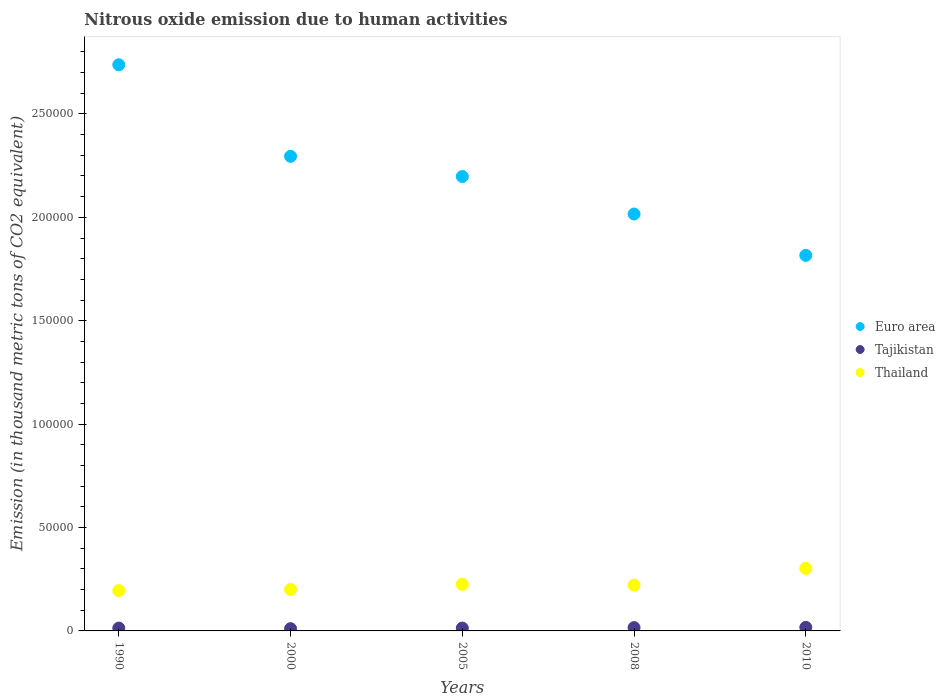How many different coloured dotlines are there?
Keep it short and to the point. 3. What is the amount of nitrous oxide emitted in Tajikistan in 2010?
Offer a very short reply. 1717.6. Across all years, what is the maximum amount of nitrous oxide emitted in Thailand?
Give a very brief answer. 3.02e+04. Across all years, what is the minimum amount of nitrous oxide emitted in Tajikistan?
Keep it short and to the point. 1092.8. In which year was the amount of nitrous oxide emitted in Euro area maximum?
Your answer should be very brief. 1990. In which year was the amount of nitrous oxide emitted in Tajikistan minimum?
Offer a very short reply. 2000. What is the total amount of nitrous oxide emitted in Euro area in the graph?
Offer a terse response. 1.11e+06. What is the difference between the amount of nitrous oxide emitted in Tajikistan in 1990 and that in 2008?
Your answer should be compact. -216.4. What is the difference between the amount of nitrous oxide emitted in Thailand in 2010 and the amount of nitrous oxide emitted in Tajikistan in 2008?
Keep it short and to the point. 2.87e+04. What is the average amount of nitrous oxide emitted in Tajikistan per year?
Keep it short and to the point. 1432.56. In the year 2005, what is the difference between the amount of nitrous oxide emitted in Tajikistan and amount of nitrous oxide emitted in Thailand?
Keep it short and to the point. -2.12e+04. In how many years, is the amount of nitrous oxide emitted in Euro area greater than 110000 thousand metric tons?
Offer a terse response. 5. What is the ratio of the amount of nitrous oxide emitted in Euro area in 1990 to that in 2005?
Provide a succinct answer. 1.25. Is the amount of nitrous oxide emitted in Thailand in 1990 less than that in 2000?
Ensure brevity in your answer.  Yes. What is the difference between the highest and the second highest amount of nitrous oxide emitted in Euro area?
Provide a short and direct response. 4.43e+04. What is the difference between the highest and the lowest amount of nitrous oxide emitted in Euro area?
Ensure brevity in your answer.  9.22e+04. Is the sum of the amount of nitrous oxide emitted in Tajikistan in 1990 and 2005 greater than the maximum amount of nitrous oxide emitted in Euro area across all years?
Provide a succinct answer. No. Is it the case that in every year, the sum of the amount of nitrous oxide emitted in Tajikistan and amount of nitrous oxide emitted in Euro area  is greater than the amount of nitrous oxide emitted in Thailand?
Offer a terse response. Yes. How many dotlines are there?
Give a very brief answer. 3. How many years are there in the graph?
Offer a terse response. 5. What is the difference between two consecutive major ticks on the Y-axis?
Provide a short and direct response. 5.00e+04. Are the values on the major ticks of Y-axis written in scientific E-notation?
Your answer should be very brief. No. Does the graph contain any zero values?
Your response must be concise. No. Does the graph contain grids?
Ensure brevity in your answer.  No. Where does the legend appear in the graph?
Your answer should be compact. Center right. How are the legend labels stacked?
Keep it short and to the point. Vertical. What is the title of the graph?
Provide a short and direct response. Nitrous oxide emission due to human activities. What is the label or title of the Y-axis?
Your answer should be very brief. Emission (in thousand metric tons of CO2 equivalent). What is the Emission (in thousand metric tons of CO2 equivalent) of Euro area in 1990?
Make the answer very short. 2.74e+05. What is the Emission (in thousand metric tons of CO2 equivalent) of Tajikistan in 1990?
Offer a terse response. 1377.2. What is the Emission (in thousand metric tons of CO2 equivalent) in Thailand in 1990?
Your answer should be compact. 1.95e+04. What is the Emission (in thousand metric tons of CO2 equivalent) of Euro area in 2000?
Provide a short and direct response. 2.30e+05. What is the Emission (in thousand metric tons of CO2 equivalent) of Tajikistan in 2000?
Provide a succinct answer. 1092.8. What is the Emission (in thousand metric tons of CO2 equivalent) of Thailand in 2000?
Provide a short and direct response. 2.01e+04. What is the Emission (in thousand metric tons of CO2 equivalent) in Euro area in 2005?
Offer a very short reply. 2.20e+05. What is the Emission (in thousand metric tons of CO2 equivalent) of Tajikistan in 2005?
Your answer should be compact. 1381.6. What is the Emission (in thousand metric tons of CO2 equivalent) of Thailand in 2005?
Ensure brevity in your answer.  2.26e+04. What is the Emission (in thousand metric tons of CO2 equivalent) in Euro area in 2008?
Provide a short and direct response. 2.02e+05. What is the Emission (in thousand metric tons of CO2 equivalent) of Tajikistan in 2008?
Provide a short and direct response. 1593.6. What is the Emission (in thousand metric tons of CO2 equivalent) of Thailand in 2008?
Offer a very short reply. 2.22e+04. What is the Emission (in thousand metric tons of CO2 equivalent) in Euro area in 2010?
Your answer should be very brief. 1.82e+05. What is the Emission (in thousand metric tons of CO2 equivalent) of Tajikistan in 2010?
Make the answer very short. 1717.6. What is the Emission (in thousand metric tons of CO2 equivalent) of Thailand in 2010?
Your answer should be compact. 3.02e+04. Across all years, what is the maximum Emission (in thousand metric tons of CO2 equivalent) of Euro area?
Offer a terse response. 2.74e+05. Across all years, what is the maximum Emission (in thousand metric tons of CO2 equivalent) of Tajikistan?
Make the answer very short. 1717.6. Across all years, what is the maximum Emission (in thousand metric tons of CO2 equivalent) in Thailand?
Keep it short and to the point. 3.02e+04. Across all years, what is the minimum Emission (in thousand metric tons of CO2 equivalent) of Euro area?
Provide a succinct answer. 1.82e+05. Across all years, what is the minimum Emission (in thousand metric tons of CO2 equivalent) in Tajikistan?
Your response must be concise. 1092.8. Across all years, what is the minimum Emission (in thousand metric tons of CO2 equivalent) in Thailand?
Your response must be concise. 1.95e+04. What is the total Emission (in thousand metric tons of CO2 equivalent) in Euro area in the graph?
Provide a succinct answer. 1.11e+06. What is the total Emission (in thousand metric tons of CO2 equivalent) in Tajikistan in the graph?
Offer a terse response. 7162.8. What is the total Emission (in thousand metric tons of CO2 equivalent) in Thailand in the graph?
Make the answer very short. 1.15e+05. What is the difference between the Emission (in thousand metric tons of CO2 equivalent) of Euro area in 1990 and that in 2000?
Make the answer very short. 4.43e+04. What is the difference between the Emission (in thousand metric tons of CO2 equivalent) of Tajikistan in 1990 and that in 2000?
Provide a succinct answer. 284.4. What is the difference between the Emission (in thousand metric tons of CO2 equivalent) in Thailand in 1990 and that in 2000?
Keep it short and to the point. -586.2. What is the difference between the Emission (in thousand metric tons of CO2 equivalent) in Euro area in 1990 and that in 2005?
Make the answer very short. 5.40e+04. What is the difference between the Emission (in thousand metric tons of CO2 equivalent) of Tajikistan in 1990 and that in 2005?
Provide a succinct answer. -4.4. What is the difference between the Emission (in thousand metric tons of CO2 equivalent) of Thailand in 1990 and that in 2005?
Provide a short and direct response. -3080.2. What is the difference between the Emission (in thousand metric tons of CO2 equivalent) in Euro area in 1990 and that in 2008?
Your response must be concise. 7.22e+04. What is the difference between the Emission (in thousand metric tons of CO2 equivalent) in Tajikistan in 1990 and that in 2008?
Keep it short and to the point. -216.4. What is the difference between the Emission (in thousand metric tons of CO2 equivalent) in Thailand in 1990 and that in 2008?
Provide a short and direct response. -2680.3. What is the difference between the Emission (in thousand metric tons of CO2 equivalent) of Euro area in 1990 and that in 2010?
Ensure brevity in your answer.  9.22e+04. What is the difference between the Emission (in thousand metric tons of CO2 equivalent) in Tajikistan in 1990 and that in 2010?
Keep it short and to the point. -340.4. What is the difference between the Emission (in thousand metric tons of CO2 equivalent) in Thailand in 1990 and that in 2010?
Provide a succinct answer. -1.08e+04. What is the difference between the Emission (in thousand metric tons of CO2 equivalent) of Euro area in 2000 and that in 2005?
Provide a short and direct response. 9758.6. What is the difference between the Emission (in thousand metric tons of CO2 equivalent) in Tajikistan in 2000 and that in 2005?
Give a very brief answer. -288.8. What is the difference between the Emission (in thousand metric tons of CO2 equivalent) in Thailand in 2000 and that in 2005?
Keep it short and to the point. -2494. What is the difference between the Emission (in thousand metric tons of CO2 equivalent) of Euro area in 2000 and that in 2008?
Make the answer very short. 2.79e+04. What is the difference between the Emission (in thousand metric tons of CO2 equivalent) of Tajikistan in 2000 and that in 2008?
Your answer should be very brief. -500.8. What is the difference between the Emission (in thousand metric tons of CO2 equivalent) in Thailand in 2000 and that in 2008?
Offer a terse response. -2094.1. What is the difference between the Emission (in thousand metric tons of CO2 equivalent) of Euro area in 2000 and that in 2010?
Your answer should be compact. 4.79e+04. What is the difference between the Emission (in thousand metric tons of CO2 equivalent) of Tajikistan in 2000 and that in 2010?
Make the answer very short. -624.8. What is the difference between the Emission (in thousand metric tons of CO2 equivalent) in Thailand in 2000 and that in 2010?
Keep it short and to the point. -1.02e+04. What is the difference between the Emission (in thousand metric tons of CO2 equivalent) of Euro area in 2005 and that in 2008?
Keep it short and to the point. 1.81e+04. What is the difference between the Emission (in thousand metric tons of CO2 equivalent) in Tajikistan in 2005 and that in 2008?
Offer a terse response. -212. What is the difference between the Emission (in thousand metric tons of CO2 equivalent) in Thailand in 2005 and that in 2008?
Give a very brief answer. 399.9. What is the difference between the Emission (in thousand metric tons of CO2 equivalent) of Euro area in 2005 and that in 2010?
Your answer should be compact. 3.82e+04. What is the difference between the Emission (in thousand metric tons of CO2 equivalent) of Tajikistan in 2005 and that in 2010?
Your answer should be compact. -336. What is the difference between the Emission (in thousand metric tons of CO2 equivalent) of Thailand in 2005 and that in 2010?
Keep it short and to the point. -7685.5. What is the difference between the Emission (in thousand metric tons of CO2 equivalent) of Euro area in 2008 and that in 2010?
Keep it short and to the point. 2.00e+04. What is the difference between the Emission (in thousand metric tons of CO2 equivalent) of Tajikistan in 2008 and that in 2010?
Give a very brief answer. -124. What is the difference between the Emission (in thousand metric tons of CO2 equivalent) of Thailand in 2008 and that in 2010?
Offer a terse response. -8085.4. What is the difference between the Emission (in thousand metric tons of CO2 equivalent) of Euro area in 1990 and the Emission (in thousand metric tons of CO2 equivalent) of Tajikistan in 2000?
Offer a very short reply. 2.73e+05. What is the difference between the Emission (in thousand metric tons of CO2 equivalent) of Euro area in 1990 and the Emission (in thousand metric tons of CO2 equivalent) of Thailand in 2000?
Give a very brief answer. 2.54e+05. What is the difference between the Emission (in thousand metric tons of CO2 equivalent) in Tajikistan in 1990 and the Emission (in thousand metric tons of CO2 equivalent) in Thailand in 2000?
Offer a terse response. -1.87e+04. What is the difference between the Emission (in thousand metric tons of CO2 equivalent) in Euro area in 1990 and the Emission (in thousand metric tons of CO2 equivalent) in Tajikistan in 2005?
Your answer should be compact. 2.72e+05. What is the difference between the Emission (in thousand metric tons of CO2 equivalent) of Euro area in 1990 and the Emission (in thousand metric tons of CO2 equivalent) of Thailand in 2005?
Give a very brief answer. 2.51e+05. What is the difference between the Emission (in thousand metric tons of CO2 equivalent) in Tajikistan in 1990 and the Emission (in thousand metric tons of CO2 equivalent) in Thailand in 2005?
Provide a succinct answer. -2.12e+04. What is the difference between the Emission (in thousand metric tons of CO2 equivalent) of Euro area in 1990 and the Emission (in thousand metric tons of CO2 equivalent) of Tajikistan in 2008?
Provide a succinct answer. 2.72e+05. What is the difference between the Emission (in thousand metric tons of CO2 equivalent) of Euro area in 1990 and the Emission (in thousand metric tons of CO2 equivalent) of Thailand in 2008?
Your answer should be very brief. 2.52e+05. What is the difference between the Emission (in thousand metric tons of CO2 equivalent) in Tajikistan in 1990 and the Emission (in thousand metric tons of CO2 equivalent) in Thailand in 2008?
Your response must be concise. -2.08e+04. What is the difference between the Emission (in thousand metric tons of CO2 equivalent) in Euro area in 1990 and the Emission (in thousand metric tons of CO2 equivalent) in Tajikistan in 2010?
Keep it short and to the point. 2.72e+05. What is the difference between the Emission (in thousand metric tons of CO2 equivalent) of Euro area in 1990 and the Emission (in thousand metric tons of CO2 equivalent) of Thailand in 2010?
Your answer should be compact. 2.44e+05. What is the difference between the Emission (in thousand metric tons of CO2 equivalent) of Tajikistan in 1990 and the Emission (in thousand metric tons of CO2 equivalent) of Thailand in 2010?
Give a very brief answer. -2.89e+04. What is the difference between the Emission (in thousand metric tons of CO2 equivalent) of Euro area in 2000 and the Emission (in thousand metric tons of CO2 equivalent) of Tajikistan in 2005?
Give a very brief answer. 2.28e+05. What is the difference between the Emission (in thousand metric tons of CO2 equivalent) in Euro area in 2000 and the Emission (in thousand metric tons of CO2 equivalent) in Thailand in 2005?
Your response must be concise. 2.07e+05. What is the difference between the Emission (in thousand metric tons of CO2 equivalent) in Tajikistan in 2000 and the Emission (in thousand metric tons of CO2 equivalent) in Thailand in 2005?
Offer a very short reply. -2.15e+04. What is the difference between the Emission (in thousand metric tons of CO2 equivalent) of Euro area in 2000 and the Emission (in thousand metric tons of CO2 equivalent) of Tajikistan in 2008?
Your answer should be compact. 2.28e+05. What is the difference between the Emission (in thousand metric tons of CO2 equivalent) of Euro area in 2000 and the Emission (in thousand metric tons of CO2 equivalent) of Thailand in 2008?
Your response must be concise. 2.07e+05. What is the difference between the Emission (in thousand metric tons of CO2 equivalent) of Tajikistan in 2000 and the Emission (in thousand metric tons of CO2 equivalent) of Thailand in 2008?
Make the answer very short. -2.11e+04. What is the difference between the Emission (in thousand metric tons of CO2 equivalent) of Euro area in 2000 and the Emission (in thousand metric tons of CO2 equivalent) of Tajikistan in 2010?
Keep it short and to the point. 2.28e+05. What is the difference between the Emission (in thousand metric tons of CO2 equivalent) in Euro area in 2000 and the Emission (in thousand metric tons of CO2 equivalent) in Thailand in 2010?
Provide a short and direct response. 1.99e+05. What is the difference between the Emission (in thousand metric tons of CO2 equivalent) in Tajikistan in 2000 and the Emission (in thousand metric tons of CO2 equivalent) in Thailand in 2010?
Provide a succinct answer. -2.92e+04. What is the difference between the Emission (in thousand metric tons of CO2 equivalent) in Euro area in 2005 and the Emission (in thousand metric tons of CO2 equivalent) in Tajikistan in 2008?
Offer a terse response. 2.18e+05. What is the difference between the Emission (in thousand metric tons of CO2 equivalent) of Euro area in 2005 and the Emission (in thousand metric tons of CO2 equivalent) of Thailand in 2008?
Your answer should be very brief. 1.98e+05. What is the difference between the Emission (in thousand metric tons of CO2 equivalent) in Tajikistan in 2005 and the Emission (in thousand metric tons of CO2 equivalent) in Thailand in 2008?
Provide a succinct answer. -2.08e+04. What is the difference between the Emission (in thousand metric tons of CO2 equivalent) of Euro area in 2005 and the Emission (in thousand metric tons of CO2 equivalent) of Tajikistan in 2010?
Your response must be concise. 2.18e+05. What is the difference between the Emission (in thousand metric tons of CO2 equivalent) in Euro area in 2005 and the Emission (in thousand metric tons of CO2 equivalent) in Thailand in 2010?
Provide a succinct answer. 1.90e+05. What is the difference between the Emission (in thousand metric tons of CO2 equivalent) of Tajikistan in 2005 and the Emission (in thousand metric tons of CO2 equivalent) of Thailand in 2010?
Provide a succinct answer. -2.89e+04. What is the difference between the Emission (in thousand metric tons of CO2 equivalent) of Euro area in 2008 and the Emission (in thousand metric tons of CO2 equivalent) of Tajikistan in 2010?
Give a very brief answer. 2.00e+05. What is the difference between the Emission (in thousand metric tons of CO2 equivalent) of Euro area in 2008 and the Emission (in thousand metric tons of CO2 equivalent) of Thailand in 2010?
Your answer should be compact. 1.71e+05. What is the difference between the Emission (in thousand metric tons of CO2 equivalent) in Tajikistan in 2008 and the Emission (in thousand metric tons of CO2 equivalent) in Thailand in 2010?
Provide a succinct answer. -2.87e+04. What is the average Emission (in thousand metric tons of CO2 equivalent) of Euro area per year?
Keep it short and to the point. 2.21e+05. What is the average Emission (in thousand metric tons of CO2 equivalent) in Tajikistan per year?
Your answer should be very brief. 1432.56. What is the average Emission (in thousand metric tons of CO2 equivalent) of Thailand per year?
Provide a succinct answer. 2.29e+04. In the year 1990, what is the difference between the Emission (in thousand metric tons of CO2 equivalent) in Euro area and Emission (in thousand metric tons of CO2 equivalent) in Tajikistan?
Your response must be concise. 2.72e+05. In the year 1990, what is the difference between the Emission (in thousand metric tons of CO2 equivalent) of Euro area and Emission (in thousand metric tons of CO2 equivalent) of Thailand?
Offer a terse response. 2.54e+05. In the year 1990, what is the difference between the Emission (in thousand metric tons of CO2 equivalent) in Tajikistan and Emission (in thousand metric tons of CO2 equivalent) in Thailand?
Provide a short and direct response. -1.81e+04. In the year 2000, what is the difference between the Emission (in thousand metric tons of CO2 equivalent) of Euro area and Emission (in thousand metric tons of CO2 equivalent) of Tajikistan?
Your answer should be compact. 2.28e+05. In the year 2000, what is the difference between the Emission (in thousand metric tons of CO2 equivalent) in Euro area and Emission (in thousand metric tons of CO2 equivalent) in Thailand?
Offer a terse response. 2.09e+05. In the year 2000, what is the difference between the Emission (in thousand metric tons of CO2 equivalent) of Tajikistan and Emission (in thousand metric tons of CO2 equivalent) of Thailand?
Ensure brevity in your answer.  -1.90e+04. In the year 2005, what is the difference between the Emission (in thousand metric tons of CO2 equivalent) of Euro area and Emission (in thousand metric tons of CO2 equivalent) of Tajikistan?
Offer a terse response. 2.18e+05. In the year 2005, what is the difference between the Emission (in thousand metric tons of CO2 equivalent) in Euro area and Emission (in thousand metric tons of CO2 equivalent) in Thailand?
Offer a very short reply. 1.97e+05. In the year 2005, what is the difference between the Emission (in thousand metric tons of CO2 equivalent) of Tajikistan and Emission (in thousand metric tons of CO2 equivalent) of Thailand?
Your answer should be compact. -2.12e+04. In the year 2008, what is the difference between the Emission (in thousand metric tons of CO2 equivalent) of Euro area and Emission (in thousand metric tons of CO2 equivalent) of Tajikistan?
Your answer should be compact. 2.00e+05. In the year 2008, what is the difference between the Emission (in thousand metric tons of CO2 equivalent) in Euro area and Emission (in thousand metric tons of CO2 equivalent) in Thailand?
Provide a short and direct response. 1.79e+05. In the year 2008, what is the difference between the Emission (in thousand metric tons of CO2 equivalent) of Tajikistan and Emission (in thousand metric tons of CO2 equivalent) of Thailand?
Provide a succinct answer. -2.06e+04. In the year 2010, what is the difference between the Emission (in thousand metric tons of CO2 equivalent) of Euro area and Emission (in thousand metric tons of CO2 equivalent) of Tajikistan?
Offer a very short reply. 1.80e+05. In the year 2010, what is the difference between the Emission (in thousand metric tons of CO2 equivalent) of Euro area and Emission (in thousand metric tons of CO2 equivalent) of Thailand?
Your answer should be compact. 1.51e+05. In the year 2010, what is the difference between the Emission (in thousand metric tons of CO2 equivalent) of Tajikistan and Emission (in thousand metric tons of CO2 equivalent) of Thailand?
Offer a terse response. -2.85e+04. What is the ratio of the Emission (in thousand metric tons of CO2 equivalent) in Euro area in 1990 to that in 2000?
Provide a short and direct response. 1.19. What is the ratio of the Emission (in thousand metric tons of CO2 equivalent) in Tajikistan in 1990 to that in 2000?
Offer a very short reply. 1.26. What is the ratio of the Emission (in thousand metric tons of CO2 equivalent) in Thailand in 1990 to that in 2000?
Make the answer very short. 0.97. What is the ratio of the Emission (in thousand metric tons of CO2 equivalent) of Euro area in 1990 to that in 2005?
Offer a terse response. 1.25. What is the ratio of the Emission (in thousand metric tons of CO2 equivalent) of Thailand in 1990 to that in 2005?
Ensure brevity in your answer.  0.86. What is the ratio of the Emission (in thousand metric tons of CO2 equivalent) in Euro area in 1990 to that in 2008?
Your answer should be compact. 1.36. What is the ratio of the Emission (in thousand metric tons of CO2 equivalent) in Tajikistan in 1990 to that in 2008?
Offer a terse response. 0.86. What is the ratio of the Emission (in thousand metric tons of CO2 equivalent) of Thailand in 1990 to that in 2008?
Provide a succinct answer. 0.88. What is the ratio of the Emission (in thousand metric tons of CO2 equivalent) in Euro area in 1990 to that in 2010?
Offer a terse response. 1.51. What is the ratio of the Emission (in thousand metric tons of CO2 equivalent) in Tajikistan in 1990 to that in 2010?
Your answer should be very brief. 0.8. What is the ratio of the Emission (in thousand metric tons of CO2 equivalent) of Thailand in 1990 to that in 2010?
Your answer should be compact. 0.64. What is the ratio of the Emission (in thousand metric tons of CO2 equivalent) in Euro area in 2000 to that in 2005?
Provide a succinct answer. 1.04. What is the ratio of the Emission (in thousand metric tons of CO2 equivalent) of Tajikistan in 2000 to that in 2005?
Keep it short and to the point. 0.79. What is the ratio of the Emission (in thousand metric tons of CO2 equivalent) in Thailand in 2000 to that in 2005?
Your response must be concise. 0.89. What is the ratio of the Emission (in thousand metric tons of CO2 equivalent) in Euro area in 2000 to that in 2008?
Provide a short and direct response. 1.14. What is the ratio of the Emission (in thousand metric tons of CO2 equivalent) in Tajikistan in 2000 to that in 2008?
Your answer should be very brief. 0.69. What is the ratio of the Emission (in thousand metric tons of CO2 equivalent) in Thailand in 2000 to that in 2008?
Offer a terse response. 0.91. What is the ratio of the Emission (in thousand metric tons of CO2 equivalent) of Euro area in 2000 to that in 2010?
Provide a succinct answer. 1.26. What is the ratio of the Emission (in thousand metric tons of CO2 equivalent) in Tajikistan in 2000 to that in 2010?
Keep it short and to the point. 0.64. What is the ratio of the Emission (in thousand metric tons of CO2 equivalent) of Thailand in 2000 to that in 2010?
Your answer should be compact. 0.66. What is the ratio of the Emission (in thousand metric tons of CO2 equivalent) of Euro area in 2005 to that in 2008?
Your response must be concise. 1.09. What is the ratio of the Emission (in thousand metric tons of CO2 equivalent) of Tajikistan in 2005 to that in 2008?
Your answer should be compact. 0.87. What is the ratio of the Emission (in thousand metric tons of CO2 equivalent) in Thailand in 2005 to that in 2008?
Ensure brevity in your answer.  1.02. What is the ratio of the Emission (in thousand metric tons of CO2 equivalent) in Euro area in 2005 to that in 2010?
Your answer should be compact. 1.21. What is the ratio of the Emission (in thousand metric tons of CO2 equivalent) of Tajikistan in 2005 to that in 2010?
Provide a succinct answer. 0.8. What is the ratio of the Emission (in thousand metric tons of CO2 equivalent) in Thailand in 2005 to that in 2010?
Provide a succinct answer. 0.75. What is the ratio of the Emission (in thousand metric tons of CO2 equivalent) of Euro area in 2008 to that in 2010?
Offer a very short reply. 1.11. What is the ratio of the Emission (in thousand metric tons of CO2 equivalent) in Tajikistan in 2008 to that in 2010?
Keep it short and to the point. 0.93. What is the ratio of the Emission (in thousand metric tons of CO2 equivalent) of Thailand in 2008 to that in 2010?
Keep it short and to the point. 0.73. What is the difference between the highest and the second highest Emission (in thousand metric tons of CO2 equivalent) of Euro area?
Provide a short and direct response. 4.43e+04. What is the difference between the highest and the second highest Emission (in thousand metric tons of CO2 equivalent) of Tajikistan?
Provide a short and direct response. 124. What is the difference between the highest and the second highest Emission (in thousand metric tons of CO2 equivalent) in Thailand?
Provide a short and direct response. 7685.5. What is the difference between the highest and the lowest Emission (in thousand metric tons of CO2 equivalent) in Euro area?
Offer a terse response. 9.22e+04. What is the difference between the highest and the lowest Emission (in thousand metric tons of CO2 equivalent) of Tajikistan?
Ensure brevity in your answer.  624.8. What is the difference between the highest and the lowest Emission (in thousand metric tons of CO2 equivalent) of Thailand?
Your answer should be very brief. 1.08e+04. 